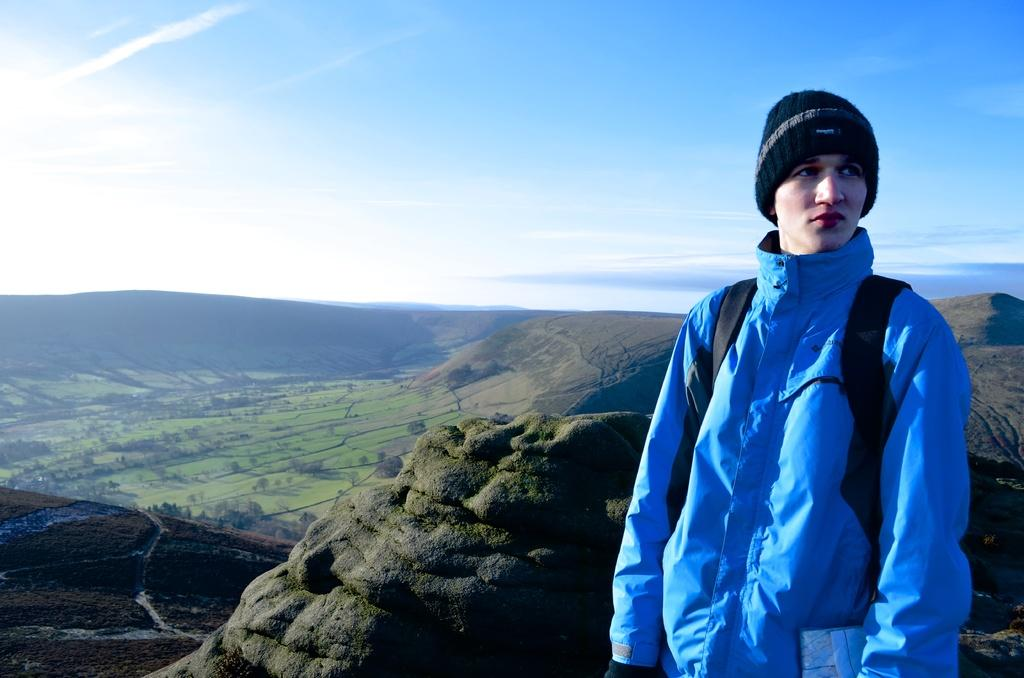Who is present in the image? There is a person in the image. What is the person wearing on their head? The person is wearing a cap. What is the person carrying in the image? The person is carrying a bag. What can be seen in the distance in the image? There are hills in the background of the image. What is visible at the top of the image? The sky is visible at the top of the image. What is the name of the yak in the image? There is no yak present in the image. How does the person's sense of direction help them navigate the hills in the image? The person's sense of direction is not mentioned in the image, so it cannot be determined how it helps them navigate the hills. 